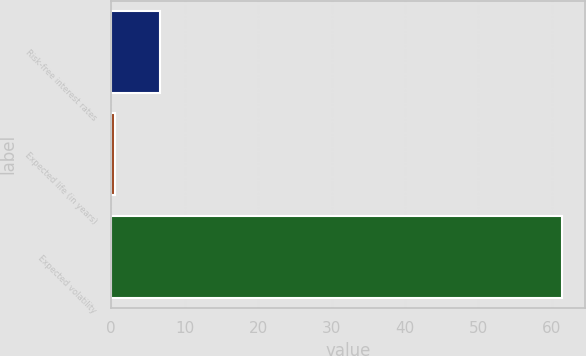<chart> <loc_0><loc_0><loc_500><loc_500><bar_chart><fcel>Risk-free interest rates<fcel>Expected life (in years)<fcel>Expected volatility<nl><fcel>6.59<fcel>0.5<fcel>61.4<nl></chart> 